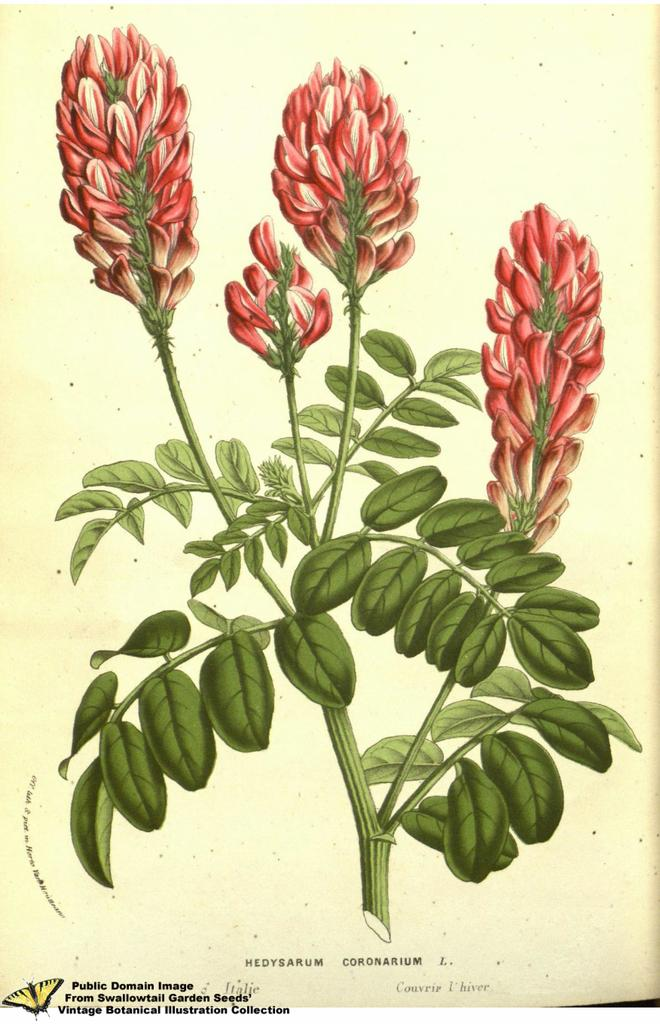What is depicted in the image? There is a painting of a flowering plant in the image. Are there any words or letters in the image? Yes, there is text in the image. How can you tell that the image is a painting? The image appears to be a painting, as it has a distinct style and texture. What year does the painting depict in the image? The provided facts do not mention a specific year, so it is impossible to determine the year depicted in the painting. What things does the painting desire in the image? The painting is an inanimate object and does not have desires. 